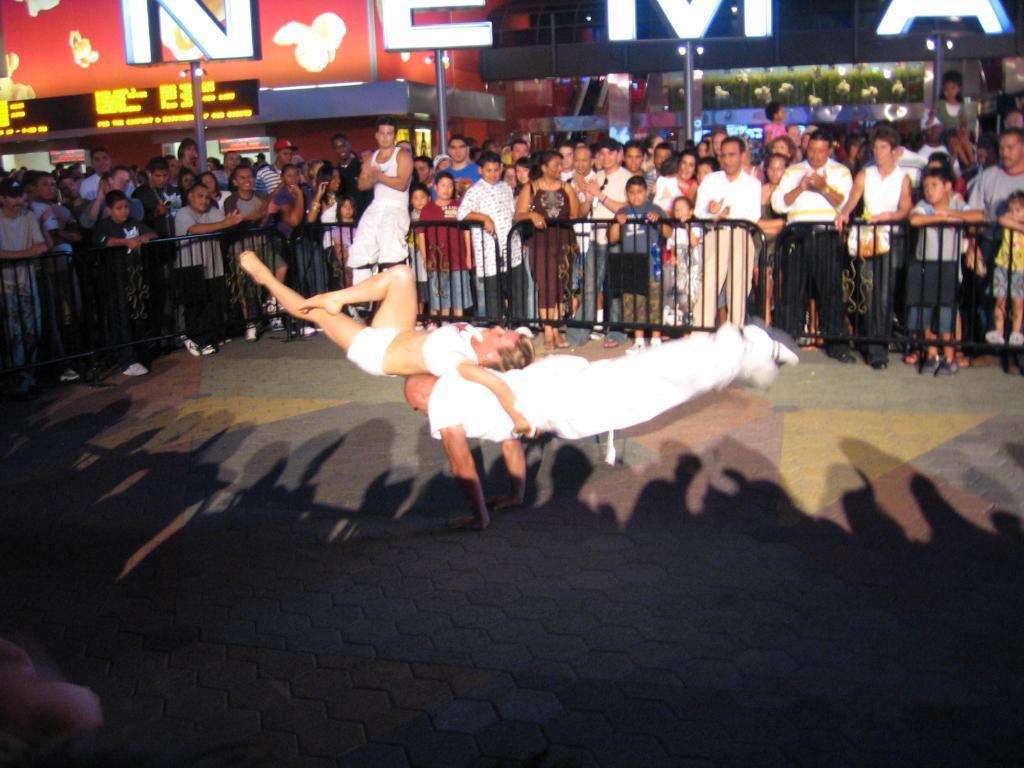In one or two sentences, can you explain what this image depicts? In this image there are few people on the road, a fence, poles and a building with the name written on it. 